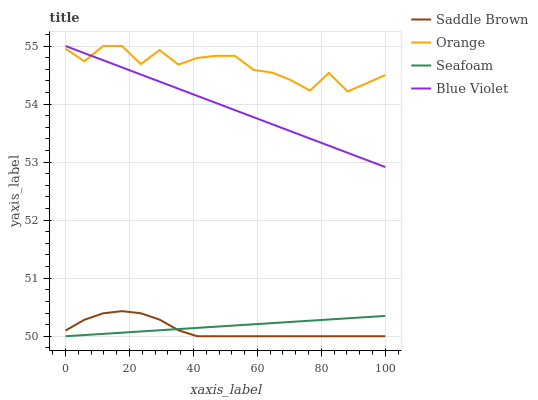Does Saddle Brown have the minimum area under the curve?
Answer yes or no. Yes. Does Orange have the maximum area under the curve?
Answer yes or no. Yes. Does Blue Violet have the minimum area under the curve?
Answer yes or no. No. Does Blue Violet have the maximum area under the curve?
Answer yes or no. No. Is Seafoam the smoothest?
Answer yes or no. Yes. Is Orange the roughest?
Answer yes or no. Yes. Is Saddle Brown the smoothest?
Answer yes or no. No. Is Saddle Brown the roughest?
Answer yes or no. No. Does Saddle Brown have the lowest value?
Answer yes or no. Yes. Does Blue Violet have the lowest value?
Answer yes or no. No. Does Blue Violet have the highest value?
Answer yes or no. Yes. Does Saddle Brown have the highest value?
Answer yes or no. No. Is Saddle Brown less than Orange?
Answer yes or no. Yes. Is Blue Violet greater than Saddle Brown?
Answer yes or no. Yes. Does Blue Violet intersect Orange?
Answer yes or no. Yes. Is Blue Violet less than Orange?
Answer yes or no. No. Is Blue Violet greater than Orange?
Answer yes or no. No. Does Saddle Brown intersect Orange?
Answer yes or no. No. 